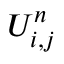<formula> <loc_0><loc_0><loc_500><loc_500>U _ { i , j } ^ { n }</formula> 